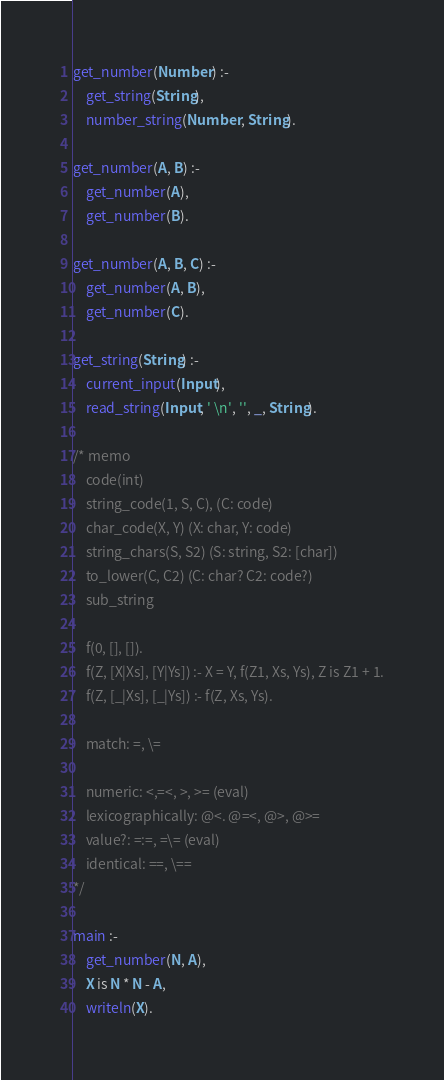<code> <loc_0><loc_0><loc_500><loc_500><_Prolog_>get_number(Number) :-
    get_string(String),
    number_string(Number, String).

get_number(A, B) :-
    get_number(A),
    get_number(B).

get_number(A, B, C) :-
    get_number(A, B),
    get_number(C).

get_string(String) :-
    current_input(Input),
    read_string(Input, ' \n', '', _, String).

/* memo
    code(int)
    string_code(1, S, C), (C: code)
    char_code(X, Y) (X: char, Y: code)
    string_chars(S, S2) (S: string, S2: [char])
    to_lower(C, C2) (C: char? C2: code?)
    sub_string

    f(0, [], []).
    f(Z, [X|Xs], [Y|Ys]) :- X = Y, f(Z1, Xs, Ys), Z is Z1 + 1.
    f(Z, [_|Xs], [_|Ys]) :- f(Z, Xs, Ys).

    match: =, \=

    numeric: <,=<, >, >= (eval)
    lexicographically: @<. @=<, @>, @>=
    value?: =:=, =\= (eval)
    identical: ==, \==
*/

main :-
    get_number(N, A),
    X is N * N - A,
    writeln(X).
</code> 